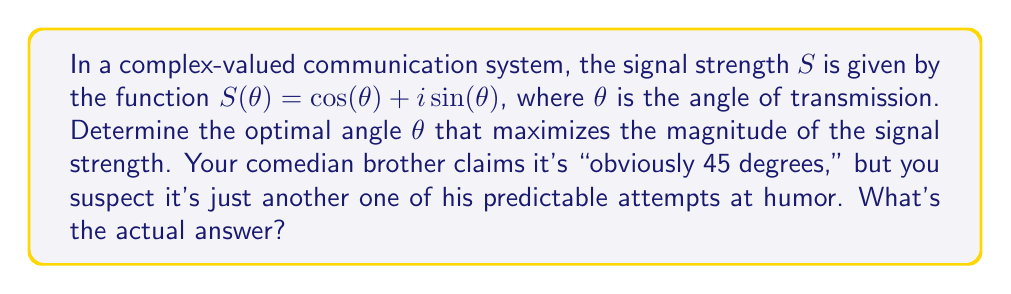Give your solution to this math problem. Let's approach this step-by-step:

1) The magnitude of a complex number $z = a + bi$ is given by $|z| = \sqrt{a^2 + b^2}$.

2) In this case, $S(\theta) = \cos(\theta) + i\sin(\theta)$, so the magnitude is:

   $|S(\theta)| = \sqrt{\cos^2(\theta) + \sin^2(\theta)}$

3) We know from trigonometry that $\cos^2(\theta) + \sin^2(\theta) = 1$ for all $\theta$.

4) Therefore, $|S(\theta)| = \sqrt{1} = 1$ for all values of $\theta$.

5) This means that the magnitude of the signal strength is constant and equal to 1, regardless of the angle $\theta$.

6) Since the magnitude is constant, any angle $\theta$ will give the maximum signal strength.

7) We can express this mathematically as $\theta \in [0, 2\pi)$, which means $\theta$ can be any angle between 0 and $2\pi$ (not including $2\pi$).
Answer: $\theta \in [0, 2\pi)$ 